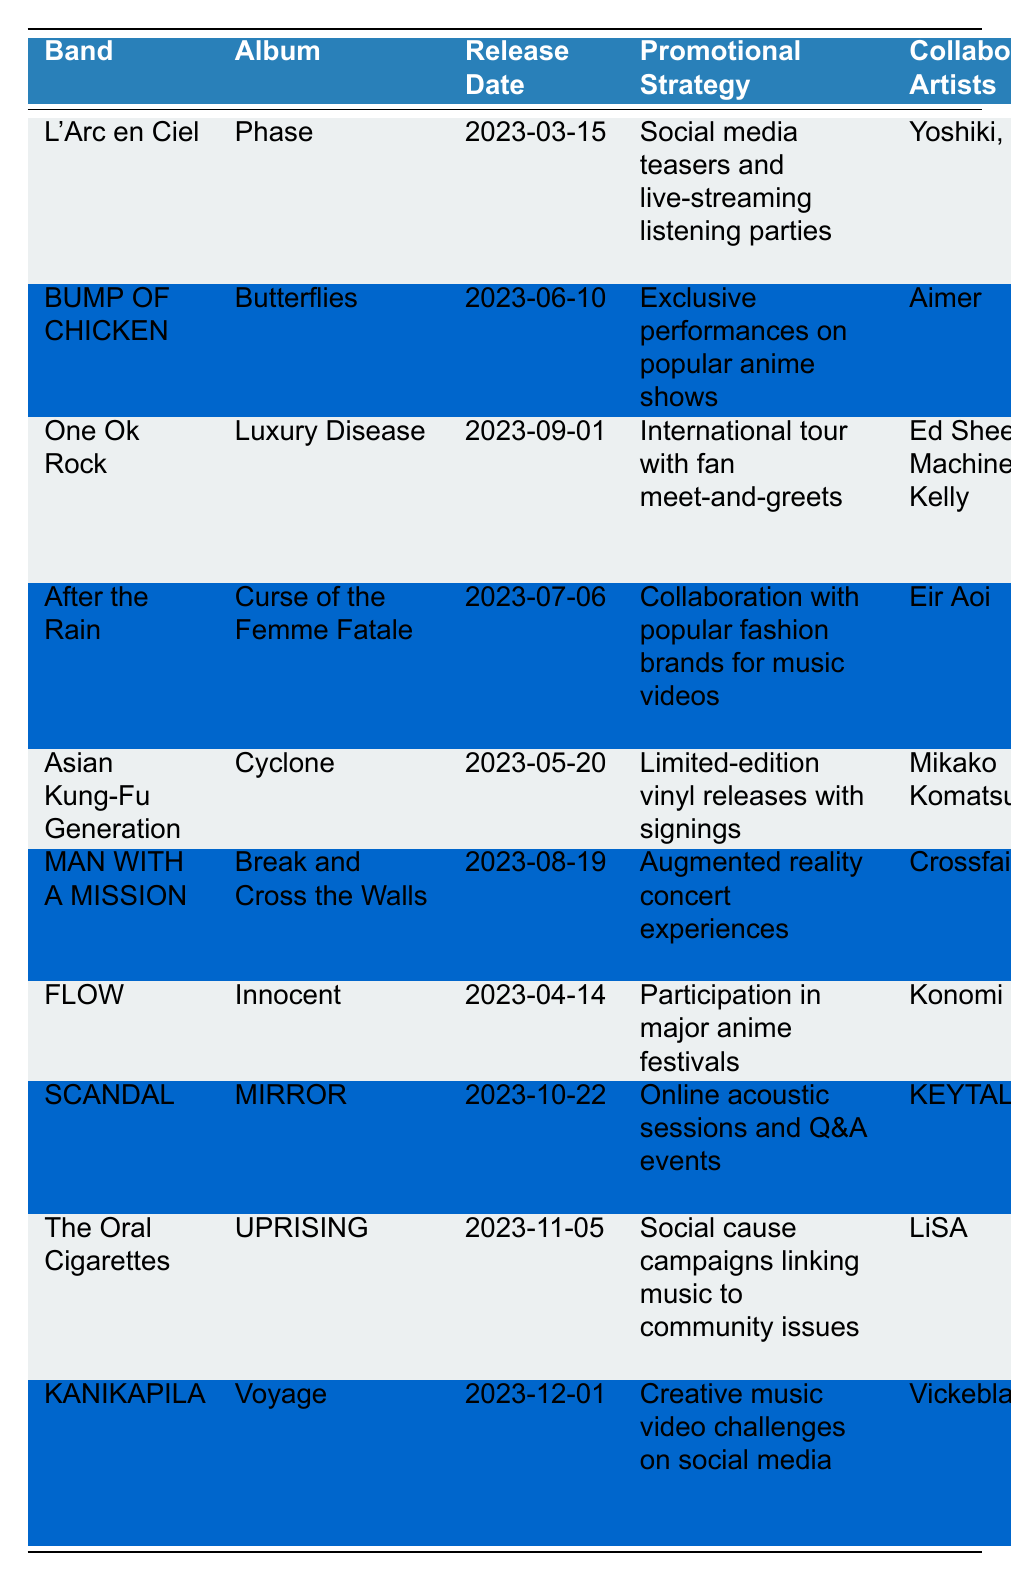What is the release date of L'Arc~en~Ciel's album? The table lists L'Arc~en~Ciel's album "Phase" with a release date of March 15, 2023.
Answer: March 15, 2023 Which J-rock band has collaborated with Ed Sheeran? The table shows that One Ok Rock's album "Luxury Disease" includes Ed Sheeran as a collaborating artist.
Answer: One Ok Rock What promotional strategy is used by BUMP OF CHICKEN for their album? According to the table, BUMP OF CHICKEN uses exclusive performances on popular anime shows as their promotional strategy for the album "Butterflies."
Answer: Exclusive performances on popular anime shows Which album has the notable track "Guilty"? The table indicates that the notable track "Guilty" belongs to After the Rain's album "Curse of the Femme Fatale."
Answer: Curse of the Femme Fatale How many albums are scheduled to be released in October 2023? The table indicates that SCANDAL's "MIRROR" is scheduled for release on October 22, 2023. This is the only album listed for October, so the count is one.
Answer: 1 What is the promotional strategy for the album "UPRISING"? According to the table, "UPRISING" by The Oral Cigarettes uses social cause campaigns linking music to community issues as its promotional strategy.
Answer: Social cause campaigns linking music to community issues Is there an album releasing after November 2023 in this table? The table shows that KANIKAPILA's album "Voyage" is set for release on December 1, 2023, which is after November. Therefore, there is an album releasing after November.
Answer: Yes Which two artists collaborate with L'Arc~en~Ciel on their album? Referring to the table, L'Arc~en~Ciel's album "Phase" features collaborations with Yoshiki and Miyavi.
Answer: Yoshiki and Miyavi Which band's promotional strategy entails collaboration with fashion brands? From the table, After the Rain uses collaboration with popular fashion brands for its music video as a promotional strategy for "Curse of the Femme Fatale."
Answer: After the Rain What is the latest album release date mentioned in the table? Checking the table, KANIKAPILA's "Voyage" has the latest release date of December 1, 2023, indicated as the last entry.
Answer: December 1, 2023 How many bands collaborate with artists in the same genre for their 2023 albums listed in the table? All bands listed in the table are in the genre J-rock, and they collaborate with various artists. Since there are 10 bands and all collaborate, the count of bands collaborating with J-rock artists is ten.
Answer: 10 